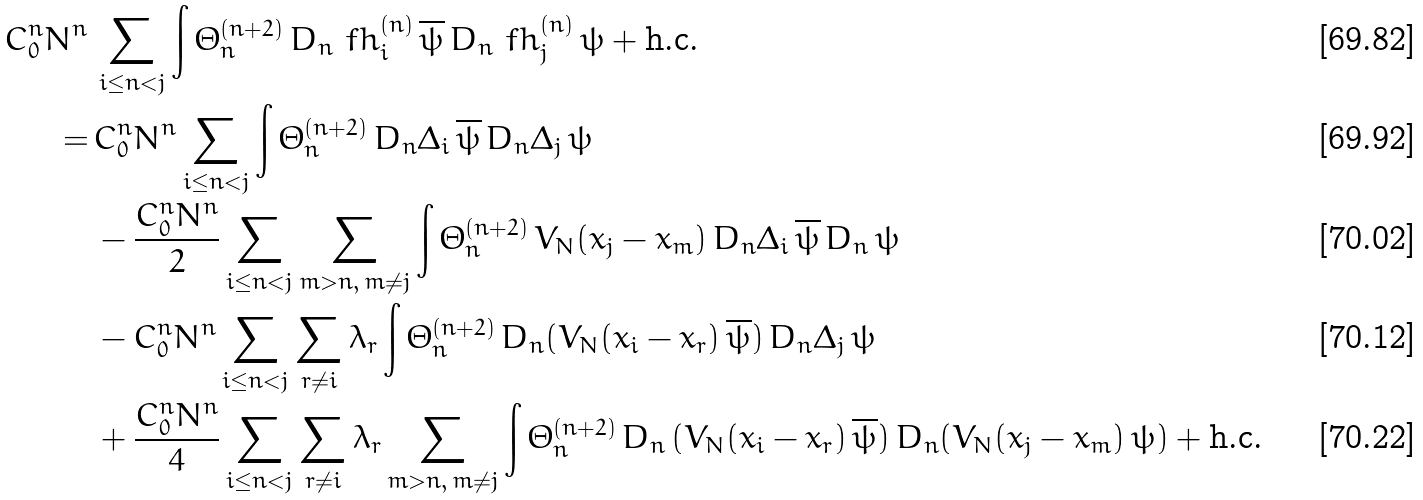<formula> <loc_0><loc_0><loc_500><loc_500>C _ { 0 } ^ { n } N ^ { n } \, & \sum _ { i \leq n < j } \int \Theta ^ { ( n + 2 ) } _ { n } \, D _ { n } \ f h ^ { ( n ) } _ { i } \, \overline { \psi } \, D _ { n } \ f h ^ { ( n ) } _ { j } \, \psi + \text {h.c.} \\ = \, & C _ { 0 } ^ { n } N ^ { n } \sum _ { i \leq n < j } \int \Theta ^ { ( n + 2 ) } _ { n } \, D _ { n } \Delta _ { i } \, \overline { \psi } \, D _ { n } \Delta _ { j } \, \psi \\ & - \frac { C _ { 0 } ^ { n } N ^ { n } } { 2 } \sum _ { i \leq n < j } \sum _ { m > n , \, m \neq j } \int \Theta ^ { ( n + 2 ) } _ { n } \, V _ { N } ( x _ { j } - x _ { m } ) \, D _ { n } \Delta _ { i } \, \overline { \psi } \, D _ { n } \, \psi \\ & - C _ { 0 } ^ { n } N ^ { n } \sum _ { i \leq n < j } \sum _ { r \neq i } \lambda _ { r } \int \Theta ^ { ( n + 2 ) } _ { n } \, D _ { n } ( V _ { N } ( x _ { i } - x _ { r } ) \, \overline { \psi } ) \, D _ { n } \Delta _ { j } \, \psi \\ & + \frac { C _ { 0 } ^ { n } N ^ { n } } { 4 } \sum _ { i \leq n < j } \sum _ { r \neq i } \lambda _ { r } \sum _ { m > n , \, m \neq j } \int \Theta ^ { ( n + 2 ) } _ { n } \, D _ { n } \, ( V _ { N } ( x _ { i } - x _ { r } ) \, \overline { \psi } ) \, D _ { n } ( V _ { N } ( x _ { j } - x _ { m } ) \, \psi ) + \text {h.c.}</formula> 